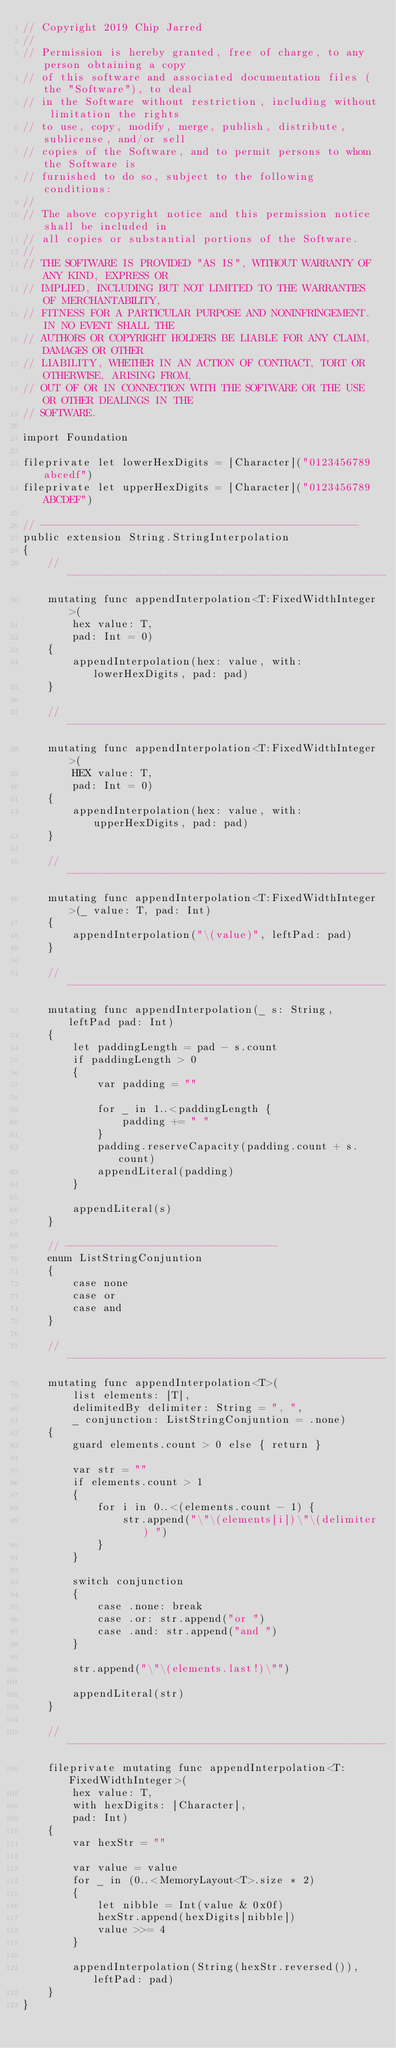Convert code to text. <code><loc_0><loc_0><loc_500><loc_500><_Swift_>// Copyright 2019 Chip Jarred
//
// Permission is hereby granted, free of charge, to any person obtaining a copy
// of this software and associated documentation files (the "Software"), to deal
// in the Software without restriction, including without limitation the rights
// to use, copy, modify, merge, publish, distribute, sublicense, and/or sell
// copies of the Software, and to permit persons to whom the Software is
// furnished to do so, subject to the following conditions:
//
// The above copyright notice and this permission notice shall be included in
// all copies or substantial portions of the Software.
//
// THE SOFTWARE IS PROVIDED "AS IS", WITHOUT WARRANTY OF ANY KIND, EXPRESS OR
// IMPLIED, INCLUDING BUT NOT LIMITED TO THE WARRANTIES OF MERCHANTABILITY,
// FITNESS FOR A PARTICULAR PURPOSE AND NONINFRINGEMENT. IN NO EVENT SHALL THE
// AUTHORS OR COPYRIGHT HOLDERS BE LIABLE FOR ANY CLAIM, DAMAGES OR OTHER
// LIABILITY, WHETHER IN AN ACTION OF CONTRACT, TORT OR OTHERWISE, ARISING FROM,
// OUT OF OR IN CONNECTION WITH THE SOFTWARE OR THE USE OR OTHER DEALINGS IN THE
// SOFTWARE.

import Foundation

fileprivate let lowerHexDigits = [Character]("0123456789abcedf")
fileprivate let upperHexDigits = [Character]("0123456789ABCDEF")

// ---------------------------------------------------
public extension String.StringInterpolation
{
    // ---------------------------------------------------
    mutating func appendInterpolation<T:FixedWidthInteger>(
        hex value: T,
        pad: Int = 0)
    {
        appendInterpolation(hex: value, with: lowerHexDigits, pad: pad)
    }
    
    // ---------------------------------------------------
    mutating func appendInterpolation<T:FixedWidthInteger>(
        HEX value: T,
        pad: Int = 0)
    {
        appendInterpolation(hex: value, with: upperHexDigits, pad: pad)
    }
    
    // ---------------------------------------------------
    mutating func appendInterpolation<T:FixedWidthInteger>(_ value: T, pad: Int)
    {
        appendInterpolation("\(value)", leftPad: pad)
    }
    
    // ---------------------------------------------------
    mutating func appendInterpolation(_ s: String, leftPad pad: Int)
    {
        let paddingLength = pad - s.count
        if paddingLength > 0
        {
            var padding = ""
            
            for _ in 1..<paddingLength {
                padding += " "
            }
            padding.reserveCapacity(padding.count + s.count)
            appendLiteral(padding)
        }
        
        appendLiteral(s)
    }
    
    // ----------------------------------
    enum ListStringConjuntion
    {
        case none
        case or
        case and
    }
    
    // ---------------------------------------------------
    mutating func appendInterpolation<T>(
        list elements: [T],
        delimitedBy delimiter: String = ", ",
        _ conjunction: ListStringConjuntion = .none)
    {
        guard elements.count > 0 else { return }
        
        var str = ""
        if elements.count > 1
        {
            for i in 0..<(elements.count - 1) {
                str.append("\"\(elements[i])\"\(delimiter) ")
            }
        }
        
        switch conjunction
        {
            case .none: break
            case .or: str.append("or ")
            case .and: str.append("and ")
        }
        
        str.append("\"\(elements.last!)\"")
        
        appendLiteral(str)
    }

    // ---------------------------------------------------
    fileprivate mutating func appendInterpolation<T:FixedWidthInteger>(
        hex value: T,
        with hexDigits: [Character],
        pad: Int)
    {
        var hexStr = ""
        
        var value = value
        for _ in (0..<MemoryLayout<T>.size * 2)
        {
            let nibble = Int(value & 0x0f)
            hexStr.append(hexDigits[nibble])
            value >>= 4
        }
        
        appendInterpolation(String(hexStr.reversed()), leftPad: pad)
    }
}
</code> 